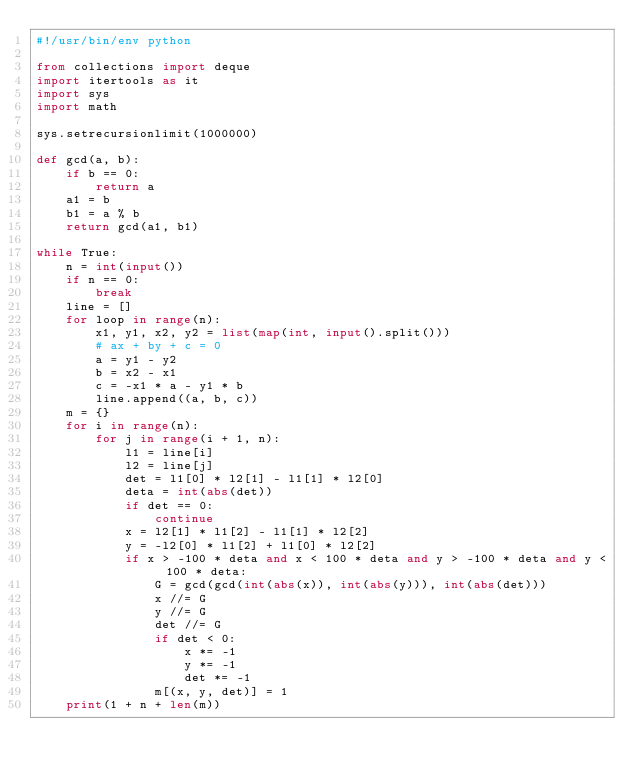<code> <loc_0><loc_0><loc_500><loc_500><_Python_>#!/usr/bin/env python

from collections import deque
import itertools as it
import sys
import math

sys.setrecursionlimit(1000000)

def gcd(a, b):
    if b == 0:
        return a
    a1 = b
    b1 = a % b
    return gcd(a1, b1)

while True:
    n = int(input())
    if n == 0:
        break
    line = []
    for loop in range(n):
        x1, y1, x2, y2 = list(map(int, input().split()))
        # ax + by + c = 0
        a = y1 - y2
        b = x2 - x1
        c = -x1 * a - y1 * b
        line.append((a, b, c))
    m = {}
    for i in range(n):
        for j in range(i + 1, n):
            l1 = line[i]
            l2 = line[j]
            det = l1[0] * l2[1] - l1[1] * l2[0]
            deta = int(abs(det))
            if det == 0:
                continue
            x = l2[1] * l1[2] - l1[1] * l2[2]
            y = -l2[0] * l1[2] + l1[0] * l2[2]
            if x > -100 * deta and x < 100 * deta and y > -100 * deta and y < 100 * deta:
                G = gcd(gcd(int(abs(x)), int(abs(y))), int(abs(det)))
                x //= G
                y //= G
                det //= G
                if det < 0:
                    x *= -1
                    y *= -1
                    det *= -1
                m[(x, y, det)] = 1
    print(1 + n + len(m))
</code> 